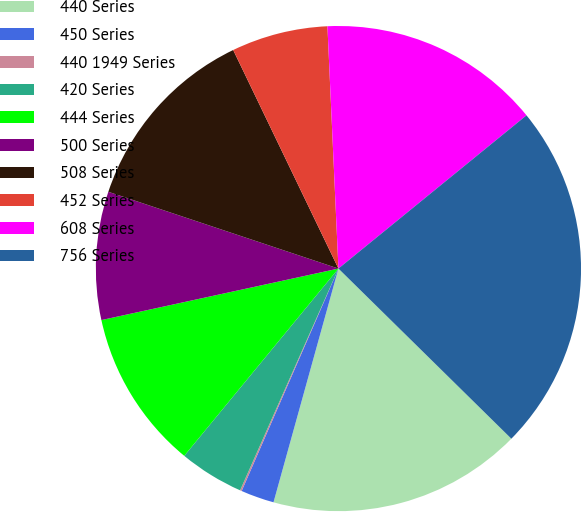Convert chart. <chart><loc_0><loc_0><loc_500><loc_500><pie_chart><fcel>440 Series<fcel>450 Series<fcel>440 1949 Series<fcel>420 Series<fcel>444 Series<fcel>500 Series<fcel>508 Series<fcel>452 Series<fcel>608 Series<fcel>756 Series<nl><fcel>16.94%<fcel>2.22%<fcel>0.11%<fcel>4.32%<fcel>10.63%<fcel>8.53%<fcel>12.73%<fcel>6.42%<fcel>14.84%<fcel>23.25%<nl></chart> 